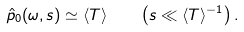Convert formula to latex. <formula><loc_0><loc_0><loc_500><loc_500>\hat { p } _ { 0 } ( \omega , s ) \simeq \langle T \rangle \quad \left ( s \ll \langle T \rangle ^ { - 1 } \right ) .</formula> 